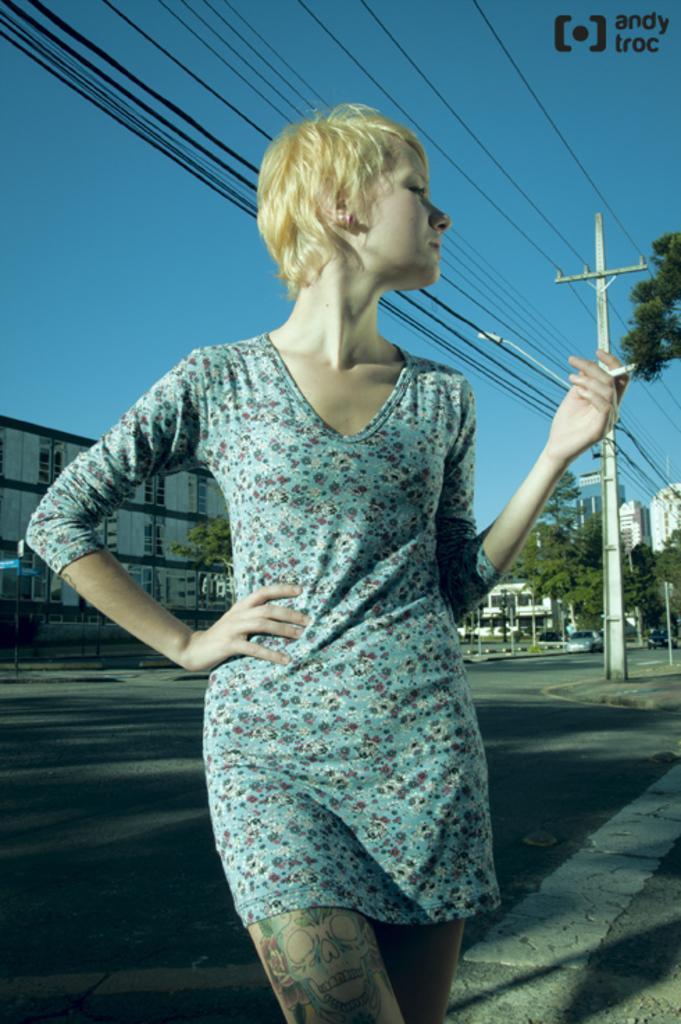Can you describe this image briefly? There is one woman standing at the bottom of this image. We can see buildings and trees in the background. The sky is at the top of this image. There is a pole and a watermark present on the right side of this image. 